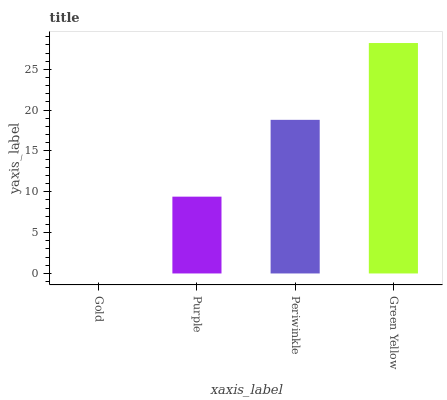Is Purple the minimum?
Answer yes or no. No. Is Purple the maximum?
Answer yes or no. No. Is Purple greater than Gold?
Answer yes or no. Yes. Is Gold less than Purple?
Answer yes or no. Yes. Is Gold greater than Purple?
Answer yes or no. No. Is Purple less than Gold?
Answer yes or no. No. Is Periwinkle the high median?
Answer yes or no. Yes. Is Purple the low median?
Answer yes or no. Yes. Is Purple the high median?
Answer yes or no. No. Is Periwinkle the low median?
Answer yes or no. No. 